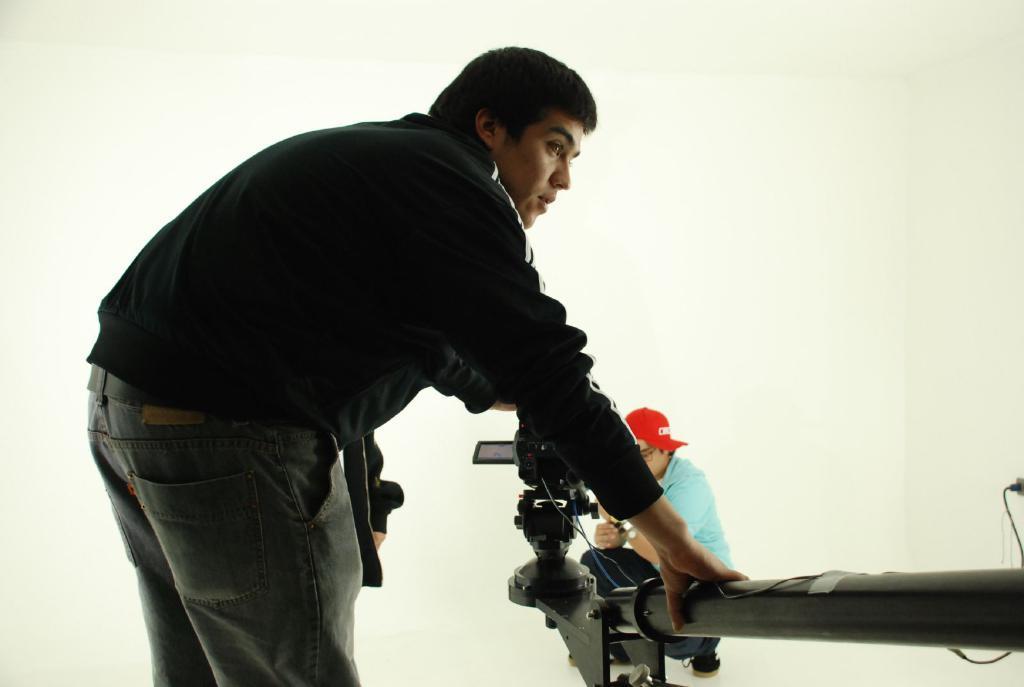Could you give a brief overview of what you see in this image? In this image, there is a person wearing clothes and sitting beside the camera arm. There is an another person on the left side of the image wearing clothes and holding a camera arm with his hand. 